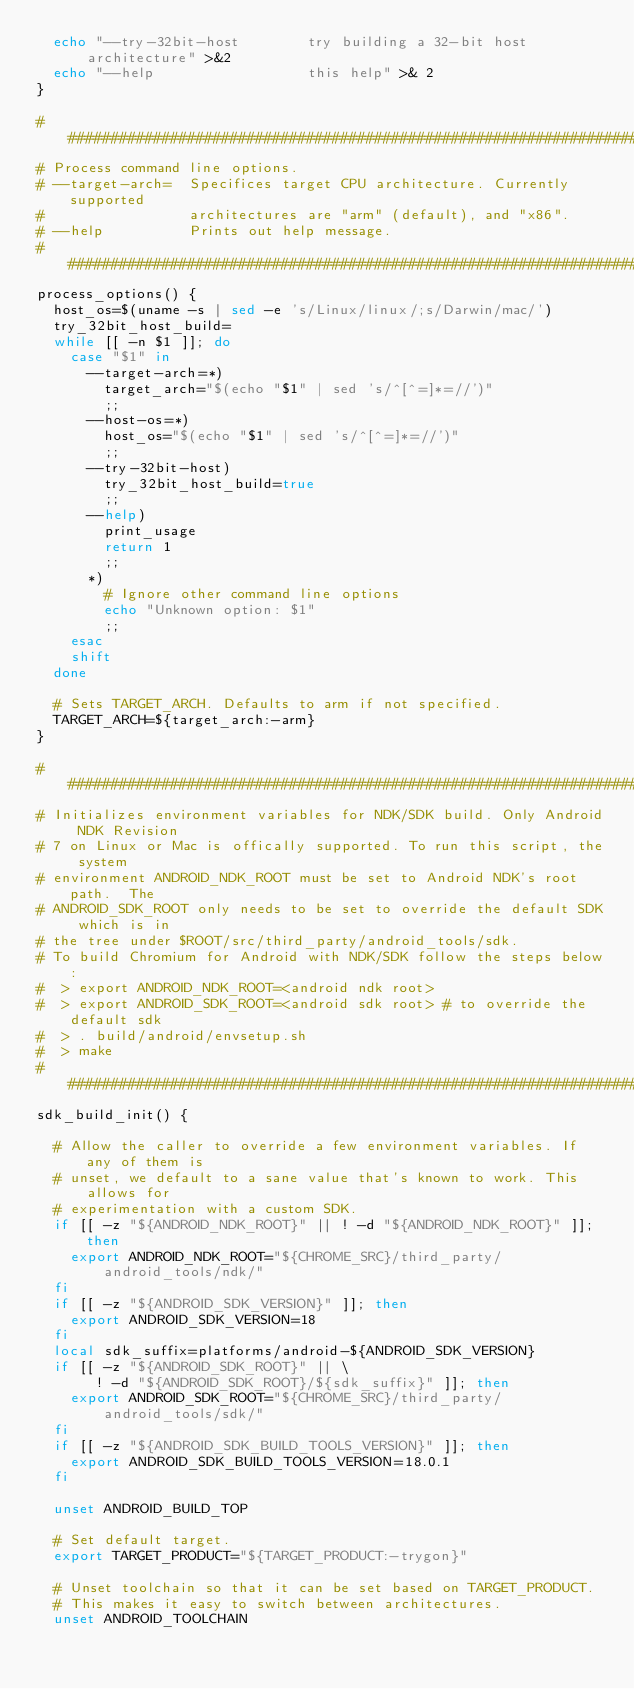Convert code to text. <code><loc_0><loc_0><loc_500><loc_500><_Bash_>  echo "--try-32bit-host        try building a 32-bit host architecture" >&2
  echo "--help                  this help" >& 2
}

################################################################################
# Process command line options.
# --target-arch=  Specifices target CPU architecture. Currently supported
#                 architectures are "arm" (default), and "x86".
# --help          Prints out help message.
################################################################################
process_options() {
  host_os=$(uname -s | sed -e 's/Linux/linux/;s/Darwin/mac/')
  try_32bit_host_build=
  while [[ -n $1 ]]; do
    case "$1" in
      --target-arch=*)
        target_arch="$(echo "$1" | sed 's/^[^=]*=//')"
        ;;
      --host-os=*)
        host_os="$(echo "$1" | sed 's/^[^=]*=//')"
        ;;
      --try-32bit-host)
        try_32bit_host_build=true
        ;;
      --help)
        print_usage
        return 1
        ;;
      *)
        # Ignore other command line options
        echo "Unknown option: $1"
        ;;
    esac
    shift
  done

  # Sets TARGET_ARCH. Defaults to arm if not specified.
  TARGET_ARCH=${target_arch:-arm}
}

################################################################################
# Initializes environment variables for NDK/SDK build. Only Android NDK Revision
# 7 on Linux or Mac is offically supported. To run this script, the system
# environment ANDROID_NDK_ROOT must be set to Android NDK's root path.  The
# ANDROID_SDK_ROOT only needs to be set to override the default SDK which is in
# the tree under $ROOT/src/third_party/android_tools/sdk.
# To build Chromium for Android with NDK/SDK follow the steps below:
#  > export ANDROID_NDK_ROOT=<android ndk root>
#  > export ANDROID_SDK_ROOT=<android sdk root> # to override the default sdk
#  > . build/android/envsetup.sh
#  > make
################################################################################
sdk_build_init() {

  # Allow the caller to override a few environment variables. If any of them is
  # unset, we default to a sane value that's known to work. This allows for
  # experimentation with a custom SDK.
  if [[ -z "${ANDROID_NDK_ROOT}" || ! -d "${ANDROID_NDK_ROOT}" ]]; then
    export ANDROID_NDK_ROOT="${CHROME_SRC}/third_party/android_tools/ndk/"
  fi
  if [[ -z "${ANDROID_SDK_VERSION}" ]]; then
    export ANDROID_SDK_VERSION=18
  fi
  local sdk_suffix=platforms/android-${ANDROID_SDK_VERSION}
  if [[ -z "${ANDROID_SDK_ROOT}" || \
       ! -d "${ANDROID_SDK_ROOT}/${sdk_suffix}" ]]; then
    export ANDROID_SDK_ROOT="${CHROME_SRC}/third_party/android_tools/sdk/"
  fi
  if [[ -z "${ANDROID_SDK_BUILD_TOOLS_VERSION}" ]]; then
    export ANDROID_SDK_BUILD_TOOLS_VERSION=18.0.1
  fi

  unset ANDROID_BUILD_TOP

  # Set default target.
  export TARGET_PRODUCT="${TARGET_PRODUCT:-trygon}"

  # Unset toolchain so that it can be set based on TARGET_PRODUCT.
  # This makes it easy to switch between architectures.
  unset ANDROID_TOOLCHAIN
</code> 